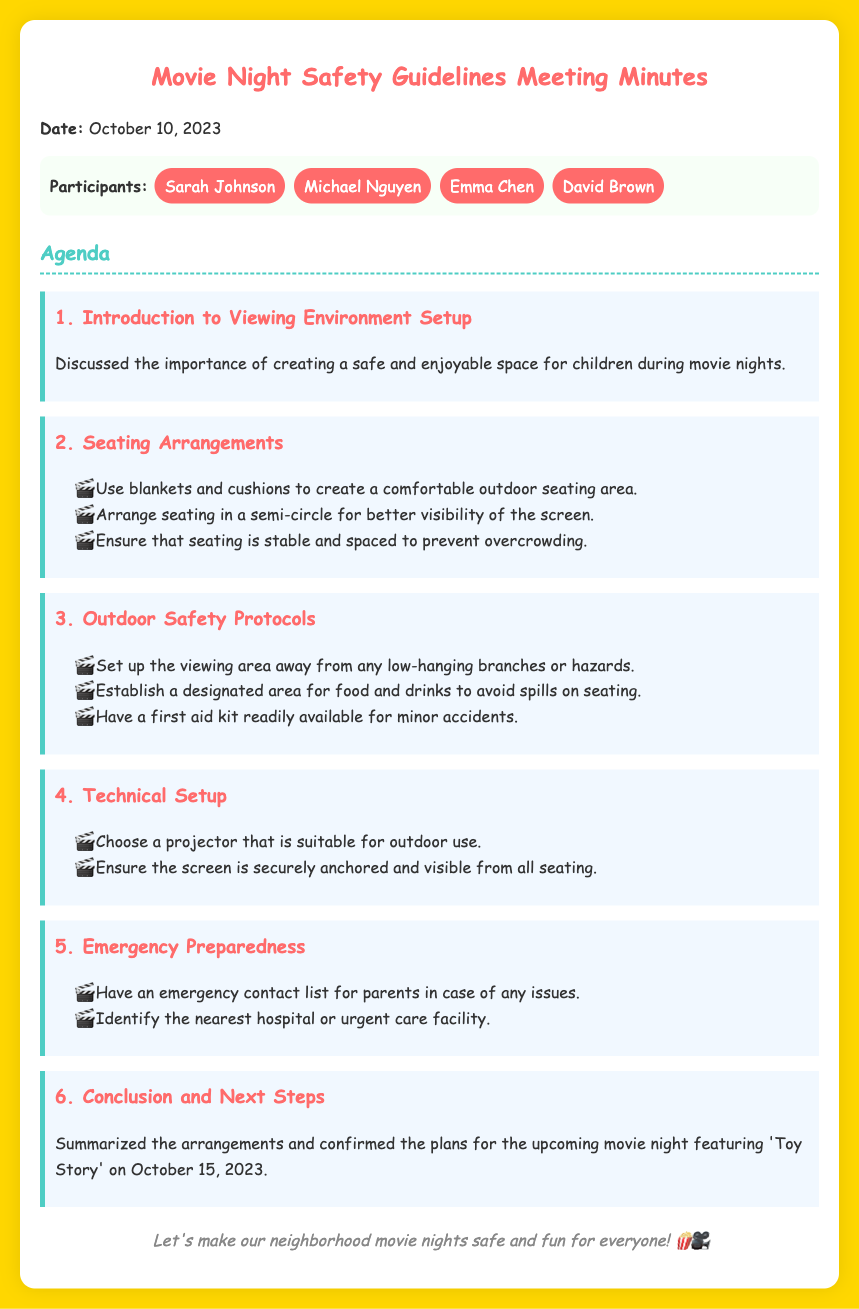what is the date of the meeting? The date of the meeting is explicitly stated in the document.
Answer: October 10, 2023 who is one of the participants? The document lists several participants by name.
Answer: Sarah Johnson what is the title of the movie featured in the upcoming movie night? The conclusion section mentions the specific movie being showcased.
Answer: Toy Story what is one seating arrangement suggestion? The document includes suggestions under the seating arrangements agenda item.
Answer: Arrange seating in a semi-circle what should be set up away from hazards? The outdoor safety protocols mention a specific area to be mindful of.
Answer: Viewing area what should be readily available for minor accidents? The outdoor safety protocols outline essentials for emergencies.
Answer: First aid kit what is the main focus of the meeting? The introduction highlights the central theme of the discussion.
Answer: Safe and enjoyable space how many agenda items were discussed? The agenda lists all topics addressed during the meeting.
Answer: Six 